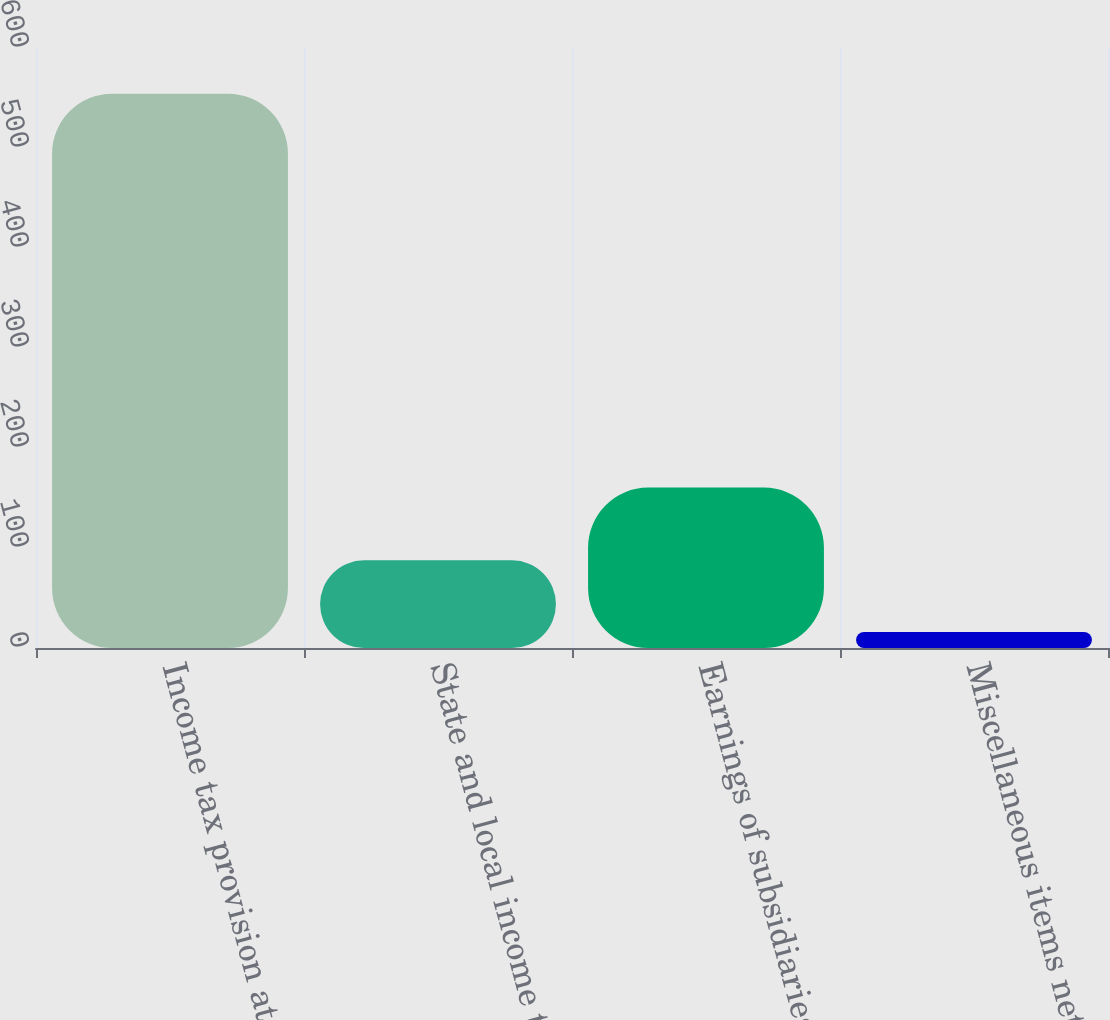<chart> <loc_0><loc_0><loc_500><loc_500><bar_chart><fcel>Income tax provision at<fcel>State and local income taxes<fcel>Earnings of subsidiaries taxed<fcel>Miscellaneous items net<nl><fcel>554.2<fcel>87.67<fcel>160.4<fcel>16<nl></chart> 